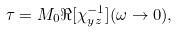<formula> <loc_0><loc_0><loc_500><loc_500>\tau = M _ { 0 } \Re [ \chi _ { y z } ^ { - 1 } ] ( \omega \rightarrow 0 ) ,</formula> 